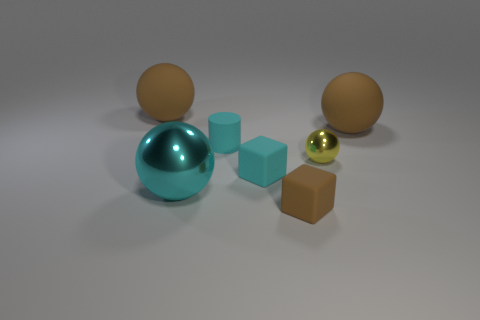Are there an equal number of brown matte balls behind the tiny brown matte block and blocks right of the yellow object? No, there are not. There are two brown matte balls behind the tiny brown matte block, while there is only one brown matte ball to the right of the yellow object. 